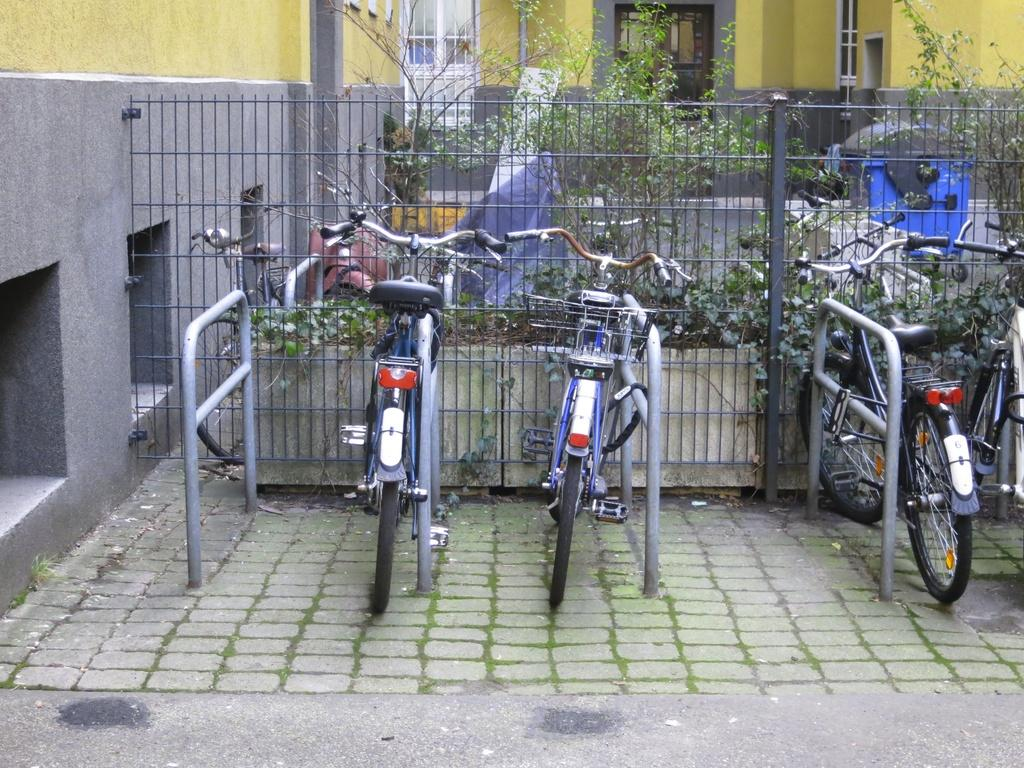What type of vehicles can be seen in the image? There are bicycles in the image. What structures are present to control or direct the flow of traffic? There are barriers in the image. What type of enclosure can be seen behind the bicycles? There is fencing visible behind the bicycles. What type of natural elements are present in the image? Plants are present in the image. What type of man-made structures can be seen in the image? There are buildings in the image. What type of receptacle is visible in the image? A dustbin is visible in the image. What type of architectural feature is present on the left side of the image? There is a wall of a building on the left side of the image. What type of stage can be seen in the image? There is no stage present in the image. 